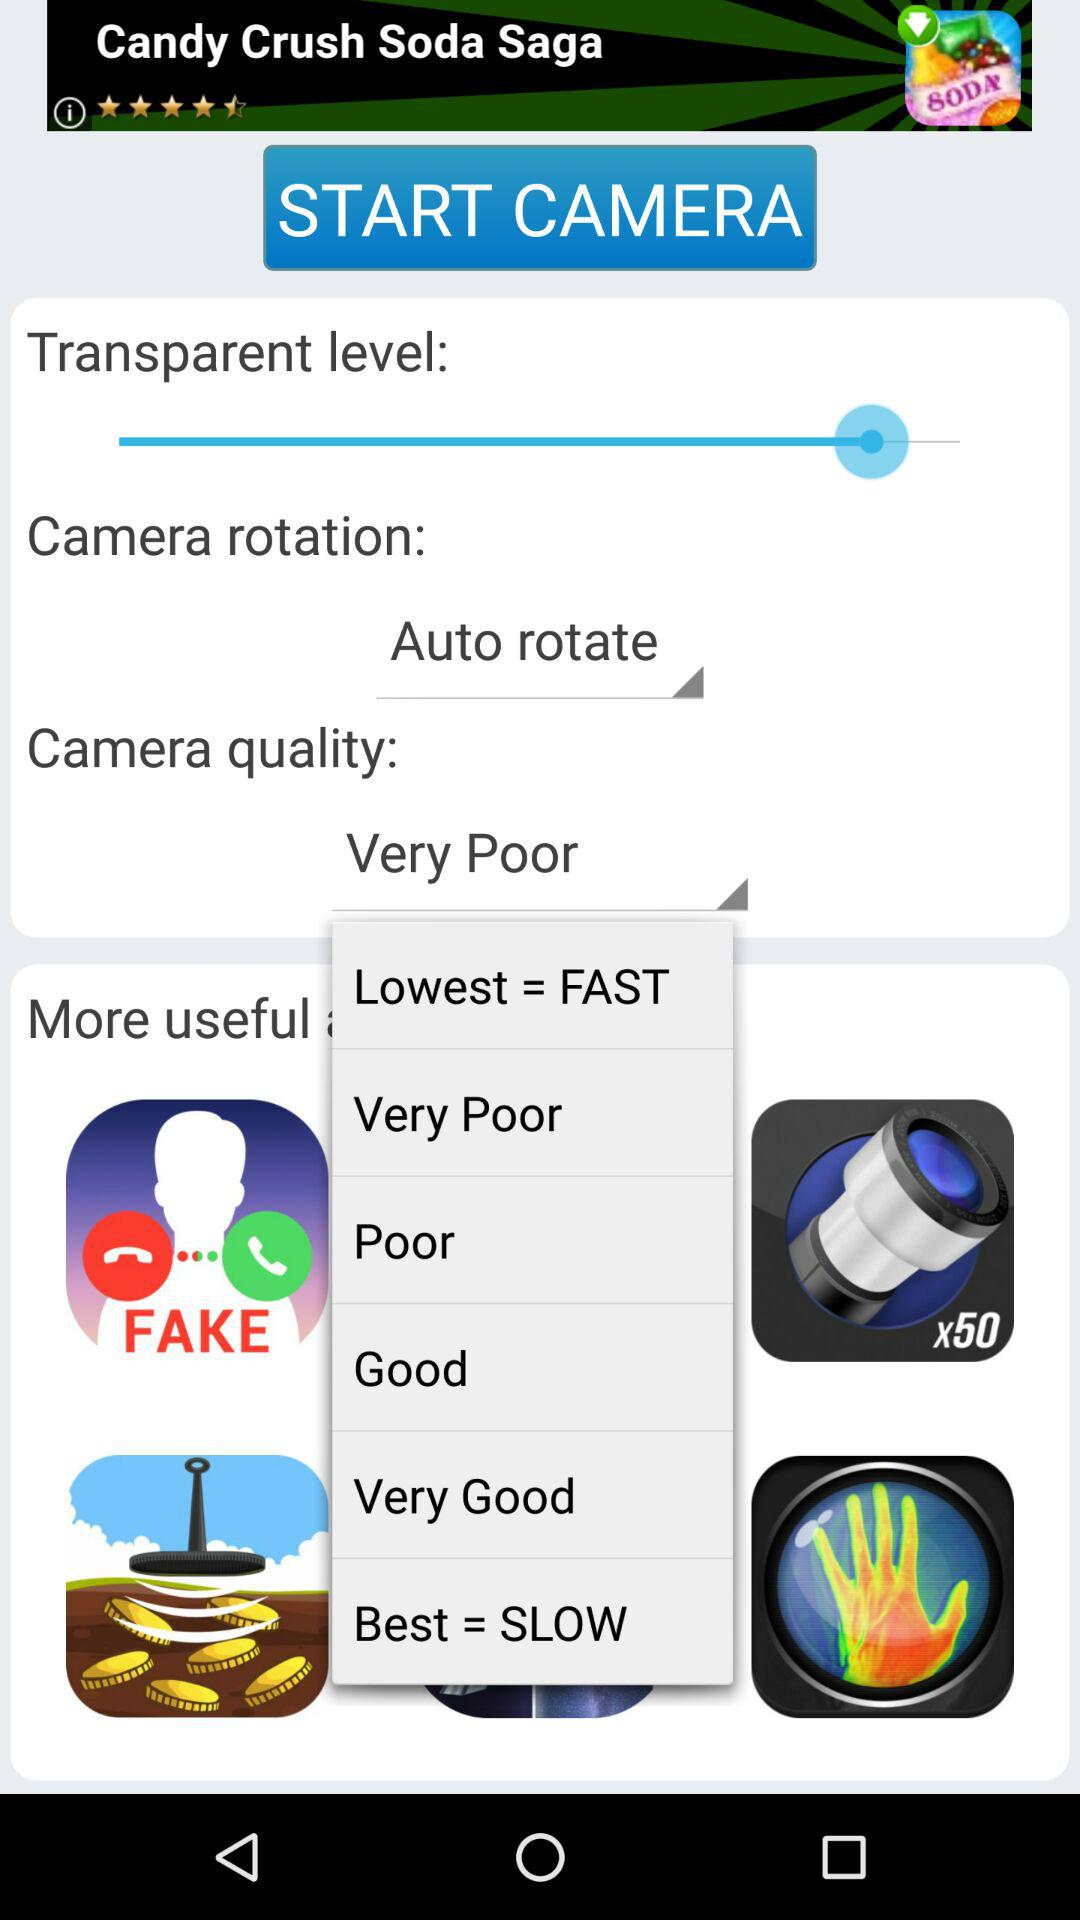What is the lowest equal to? The lowest is equal to "FAST". 